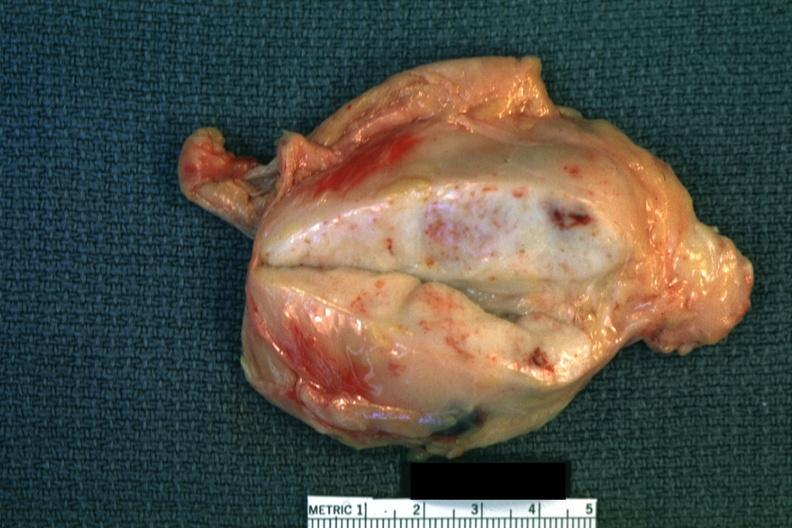does adenocarcinoma show close-up enlarge white node with focal necrosis quite good?
Answer the question using a single word or phrase. No 